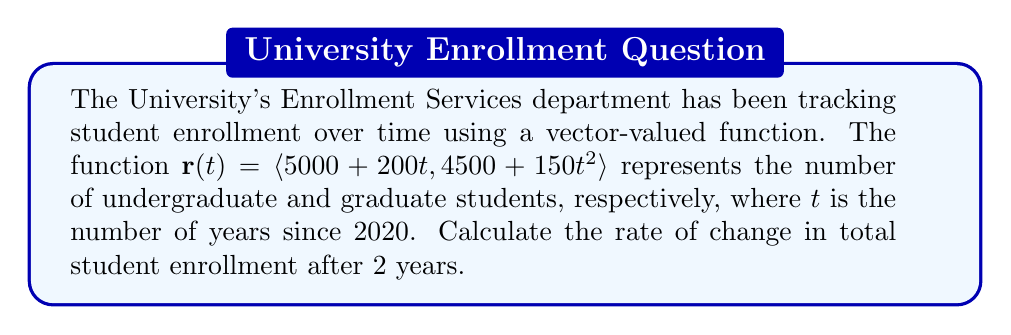Help me with this question. To solve this problem, we'll follow these steps:

1) The total student enrollment is the sum of undergraduate and graduate students:
   $E(t) = (5000 + 200t) + (4500 + 150t^2)$

2) To find the rate of change, we need to differentiate $E(t)$ with respect to $t$:
   $$\frac{dE}{dt} = \frac{d}{dt}(5000 + 200t) + \frac{d}{dt}(4500 + 150t^2)$$
   $$\frac{dE}{dt} = 200 + 300t$$

3) This gives us the instantaneous rate of change at any time $t$.

4) To find the rate of change after 2 years, we substitute $t=2$ into our equation:
   $$\frac{dE}{dt}\bigg|_{t=2} = 200 + 300(2) = 200 + 600 = 800$$

Therefore, after 2 years, the rate of change in total student enrollment is 800 students per year.
Answer: 800 students/year 